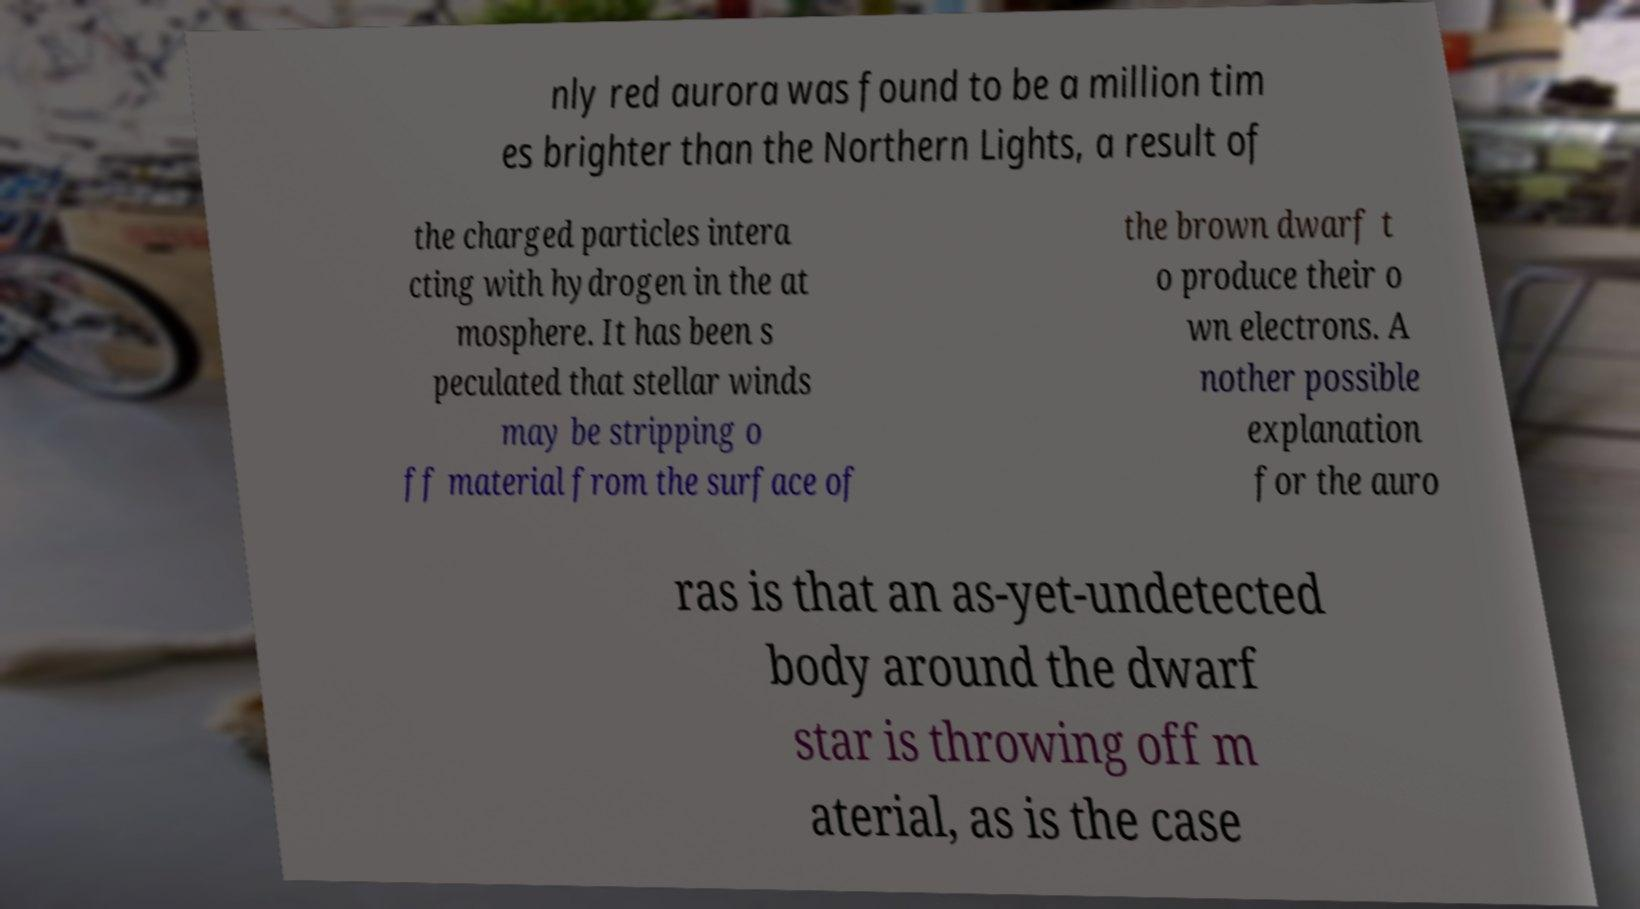Please identify and transcribe the text found in this image. nly red aurora was found to be a million tim es brighter than the Northern Lights, a result of the charged particles intera cting with hydrogen in the at mosphere. It has been s peculated that stellar winds may be stripping o ff material from the surface of the brown dwarf t o produce their o wn electrons. A nother possible explanation for the auro ras is that an as-yet-undetected body around the dwarf star is throwing off m aterial, as is the case 